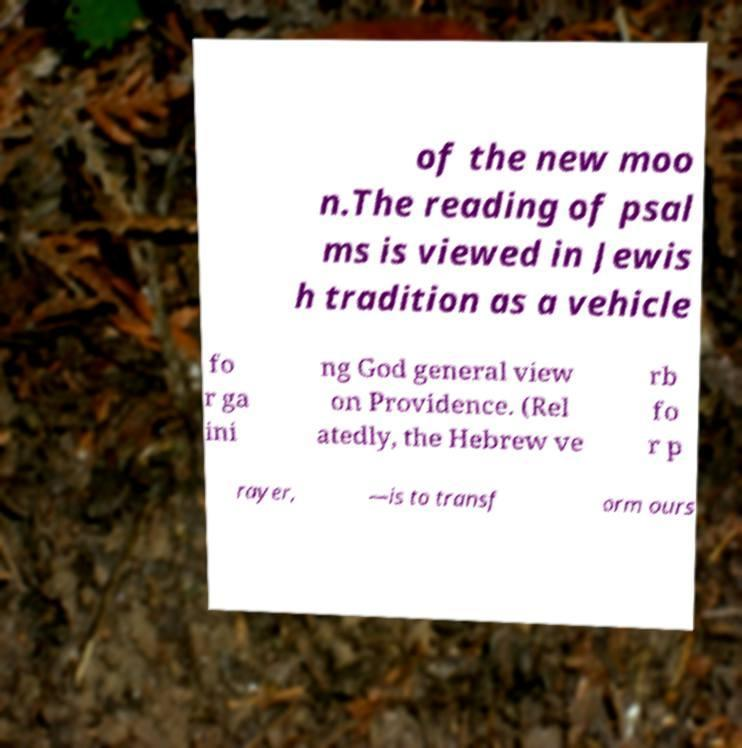Could you extract and type out the text from this image? of the new moo n.The reading of psal ms is viewed in Jewis h tradition as a vehicle fo r ga ini ng God general view on Providence. (Rel atedly, the Hebrew ve rb fo r p rayer, —is to transf orm ours 